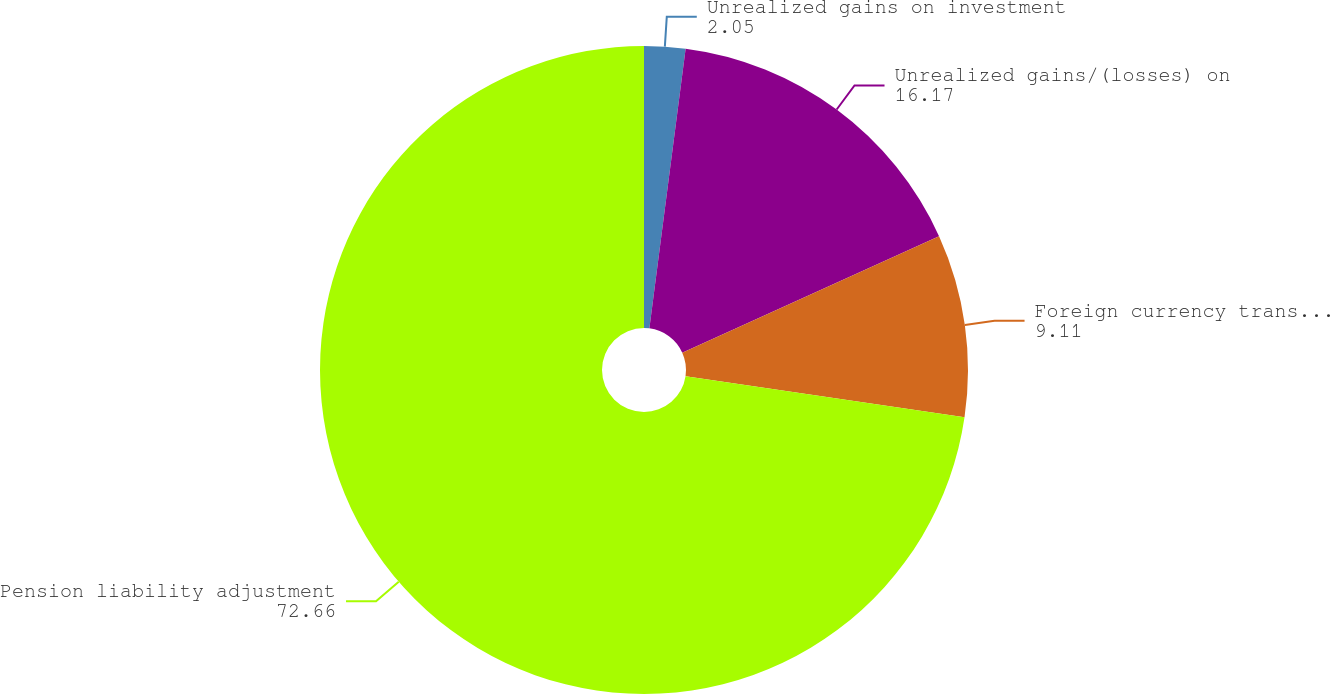Convert chart to OTSL. <chart><loc_0><loc_0><loc_500><loc_500><pie_chart><fcel>Unrealized gains on investment<fcel>Unrealized gains/(losses) on<fcel>Foreign currency translation<fcel>Pension liability adjustment<nl><fcel>2.05%<fcel>16.17%<fcel>9.11%<fcel>72.66%<nl></chart> 